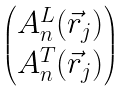Convert formula to latex. <formula><loc_0><loc_0><loc_500><loc_500>\begin{pmatrix} A _ { n } ^ { L } ( \vec { r } _ { j } ) \\ A _ { n } ^ { T } ( \vec { r } _ { j } ) \end{pmatrix}</formula> 